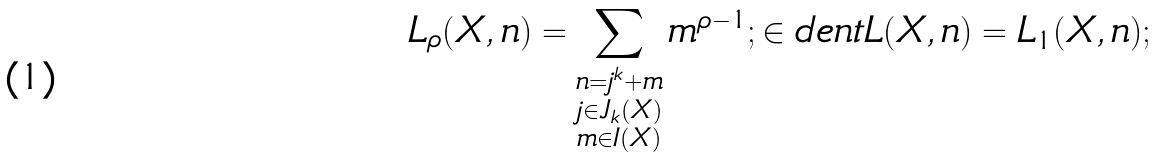Convert formula to latex. <formula><loc_0><loc_0><loc_500><loc_500>L _ { \rho } ( X , n ) = \sum _ { \substack { n = j ^ { k } + m \\ j \in J _ { k } ( X ) \\ m \in I ( X ) } } m ^ { \rho - 1 } ; \in d e n t L ( X , n ) = L _ { 1 } ( X , n ) ;</formula> 